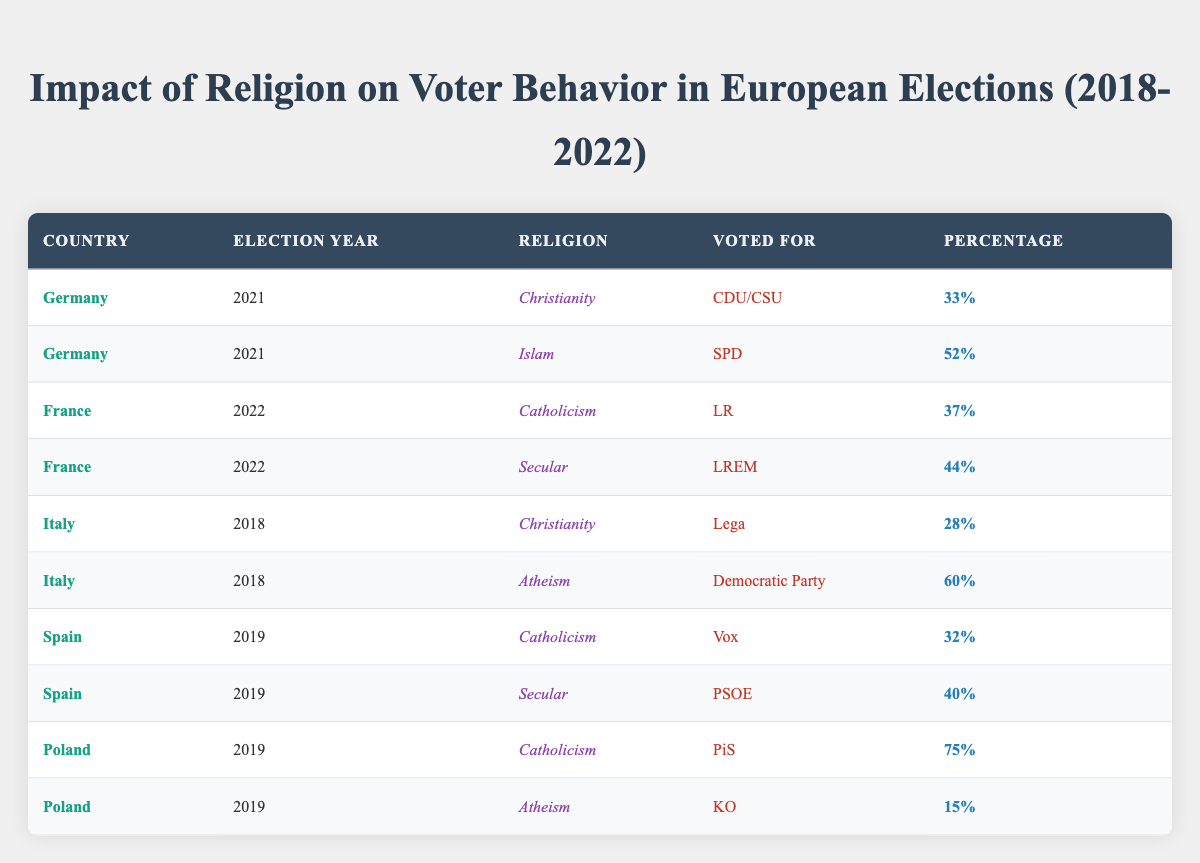What percentage of German voters who identified as Muslim voted for SPD in 2021? From the row corresponding to Germany in the 2021 column for Islam, the table indicates that 52% of Muslim voters voted for SPD.
Answer: 52% Which party received the highest percentage of votes from Catholic voters in Poland in 2019? The table shows that Catholic voters in Poland overwhelmingly voted for PiS, with a percentage of 75%, which is higher than any other options in the table.
Answer: PiS What was the average percentage of votes for secular voters in both France and Spain during their respective elections? Secular voters in France voted for LREM at 44% and in Spain for PSOE at 40%. The average percentage is calculated as (44% + 40%) / 2 = 42%.
Answer: 42% Did any Atheist voters in Italy favor the Democratic Party in 2018? Yes, according to the table, 60% of Atheist voters in Italy voted for the Democratic Party in 2018.
Answer: Yes Which religion had the lowest percentage of votes for Lega in Italy during the 2018 election? The data shows that 28% of Christian voters voted for Lega, while Atheist voters did not vote for Lega at all. Hence, the lowest percentage is from Christianity voting for Lega.
Answer: Christianity 